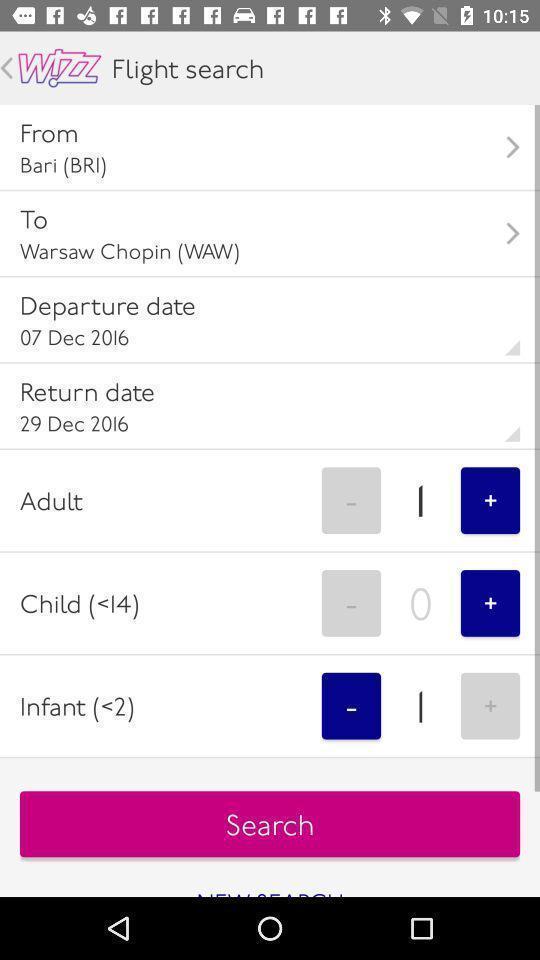Give me a narrative description of this picture. Page of a flight booking app. 